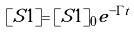<formula> <loc_0><loc_0><loc_500><loc_500>[ S 1 ] = [ S 1 ] _ { 0 } e ^ { - \Gamma t }</formula> 